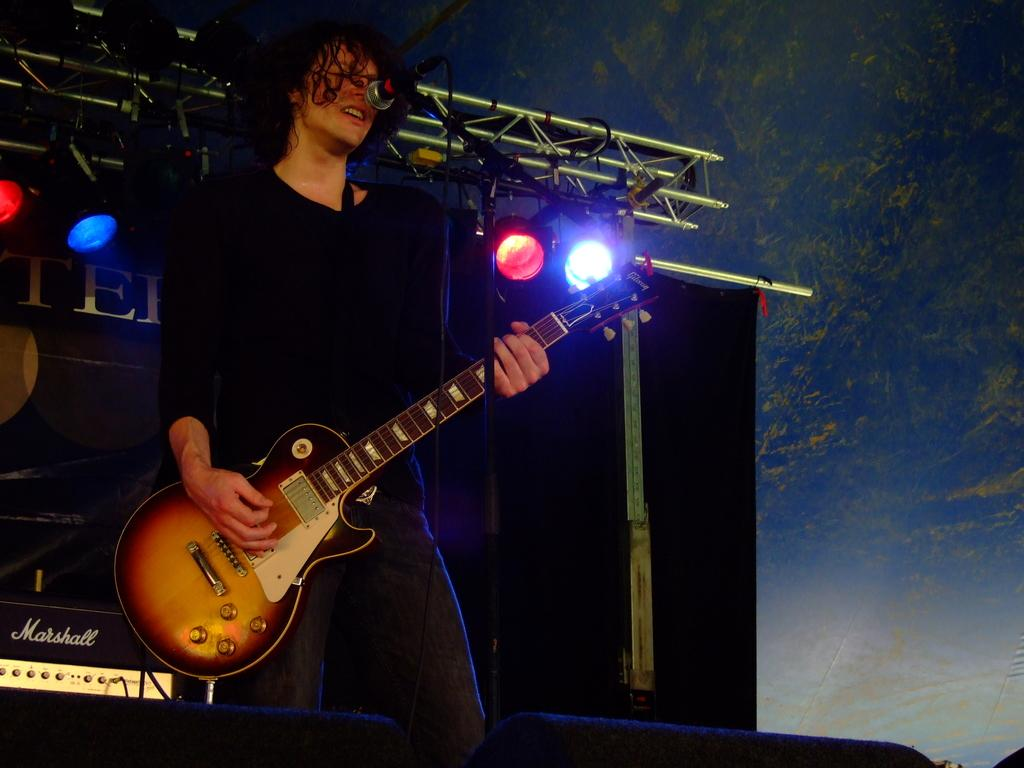What is the man in the image doing? The man is playing a guitar and singing. What instrument is the man playing in the image? The man is playing a guitar. Can you describe the background of the image? There is a light visible in the background of the image. What type of cherry is the man holding in the image? There is no cherry present in the image; the man is playing a guitar and singing. What scent can be detected in the image? There is no mention of a scent in the image, as it focuses on the man playing a guitar and singing. 